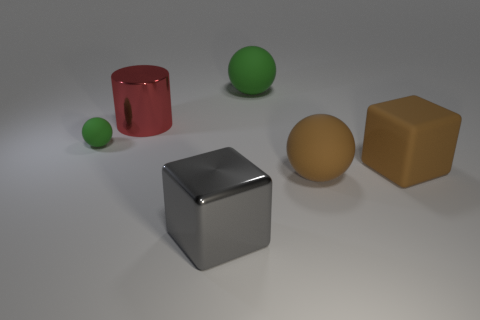What material is the big object that is to the right of the rubber ball that is on the right side of the green thing on the right side of the big red object? The big object to the right of the rubber ball, which is itself to the right of the small green ball and on the right side of the larger red cylinder, is a cube that appears to be made of metal, given its shiny, reflective surface. 